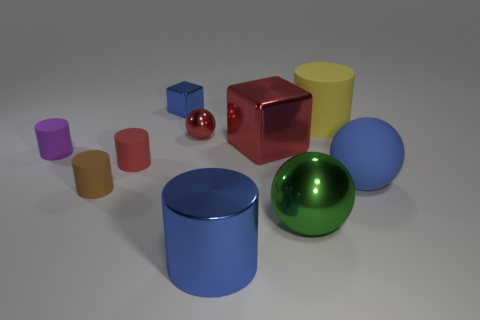Subtract all big balls. How many balls are left? 1 Subtract 2 cylinders. How many cylinders are left? 3 Subtract all large green metallic things. Subtract all big rubber things. How many objects are left? 7 Add 4 small objects. How many small objects are left? 9 Add 6 gray matte spheres. How many gray matte spheres exist? 6 Subtract all yellow cylinders. How many cylinders are left? 4 Subtract 1 green spheres. How many objects are left? 9 Subtract all blocks. How many objects are left? 8 Subtract all blue cubes. Subtract all red cylinders. How many cubes are left? 1 